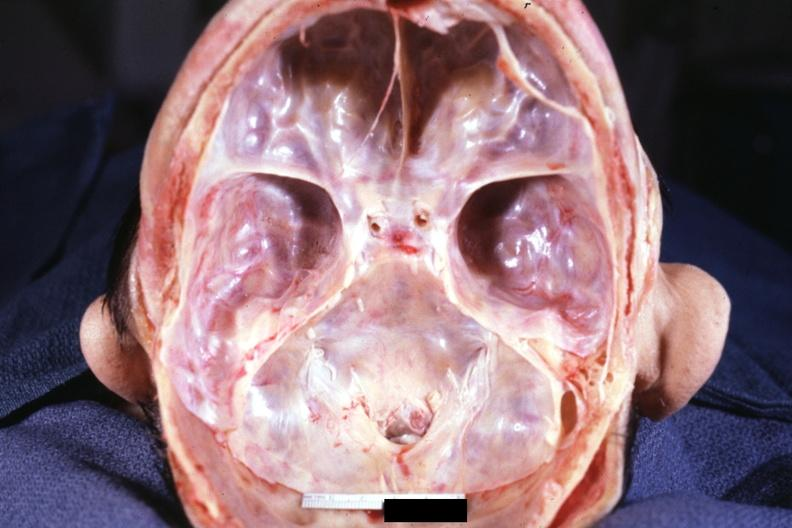what does this image show?
Answer the question using a single word or phrase. Stenosis of foramen magnum due to subluxation of atlas vertebra case 31 